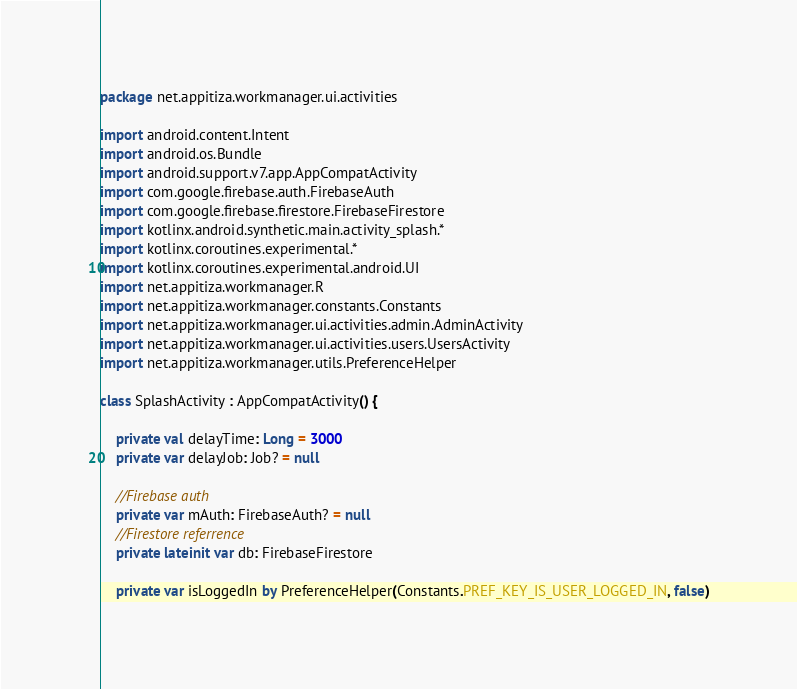Convert code to text. <code><loc_0><loc_0><loc_500><loc_500><_Kotlin_>package net.appitiza.workmanager.ui.activities

import android.content.Intent
import android.os.Bundle
import android.support.v7.app.AppCompatActivity
import com.google.firebase.auth.FirebaseAuth
import com.google.firebase.firestore.FirebaseFirestore
import kotlinx.android.synthetic.main.activity_splash.*
import kotlinx.coroutines.experimental.*
import kotlinx.coroutines.experimental.android.UI
import net.appitiza.workmanager.R
import net.appitiza.workmanager.constants.Constants
import net.appitiza.workmanager.ui.activities.admin.AdminActivity
import net.appitiza.workmanager.ui.activities.users.UsersActivity
import net.appitiza.workmanager.utils.PreferenceHelper

class SplashActivity : AppCompatActivity() {

    private val delayTime: Long = 3000
    private var delayJob: Job? = null

    //Firebase auth
    private var mAuth: FirebaseAuth? = null
    //Firestore referrence
    private lateinit var db: FirebaseFirestore

    private var isLoggedIn by PreferenceHelper(Constants.PREF_KEY_IS_USER_LOGGED_IN, false)</code> 